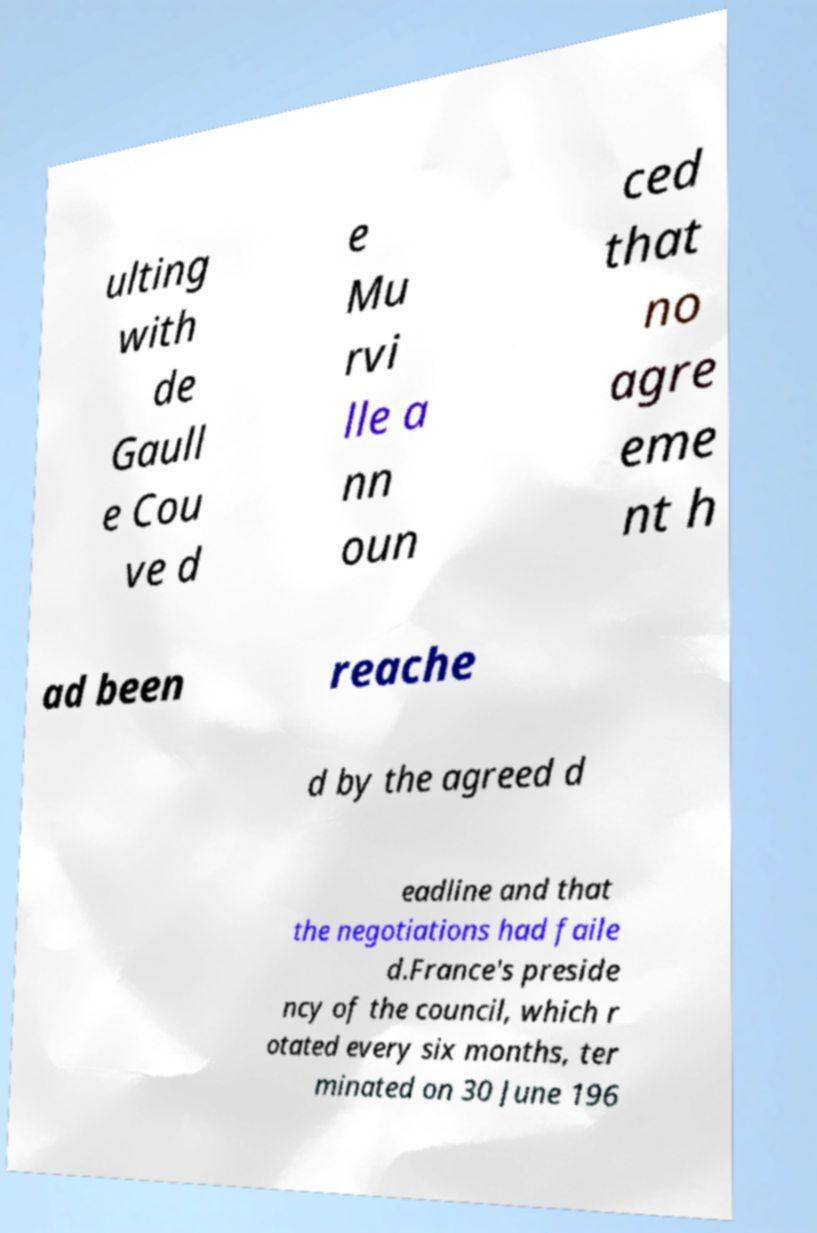There's text embedded in this image that I need extracted. Can you transcribe it verbatim? ulting with de Gaull e Cou ve d e Mu rvi lle a nn oun ced that no agre eme nt h ad been reache d by the agreed d eadline and that the negotiations had faile d.France's preside ncy of the council, which r otated every six months, ter minated on 30 June 196 